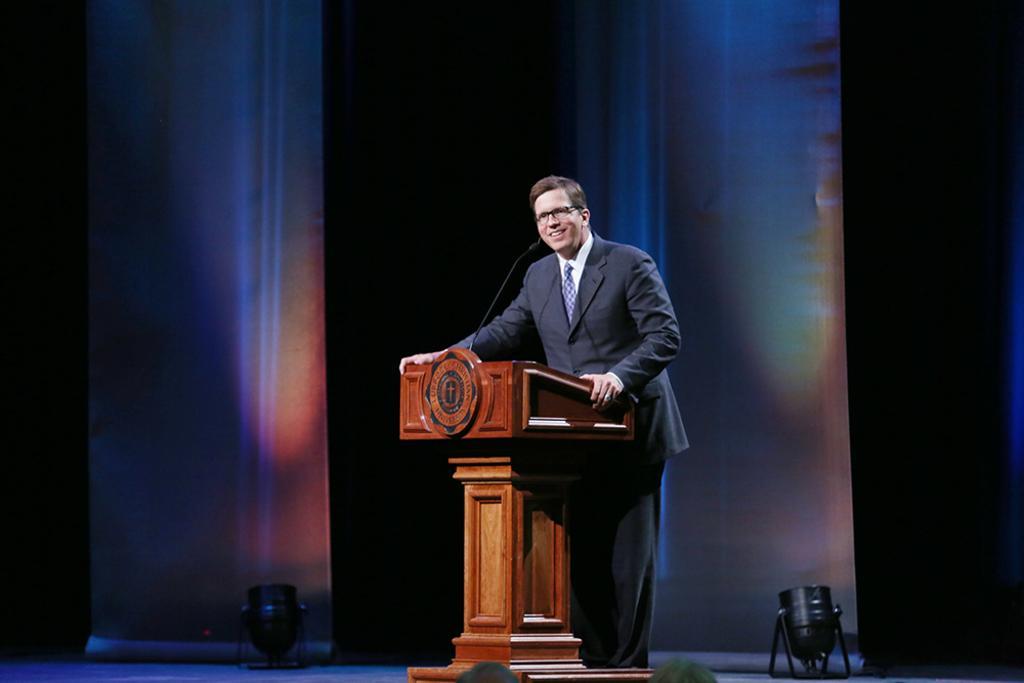Can you describe this image briefly? In this image there is a person standing on the stage. He is wearing suit and tie. Before him there is a podium having a mike on it. On both sides of him there are lights kept on the stage. 